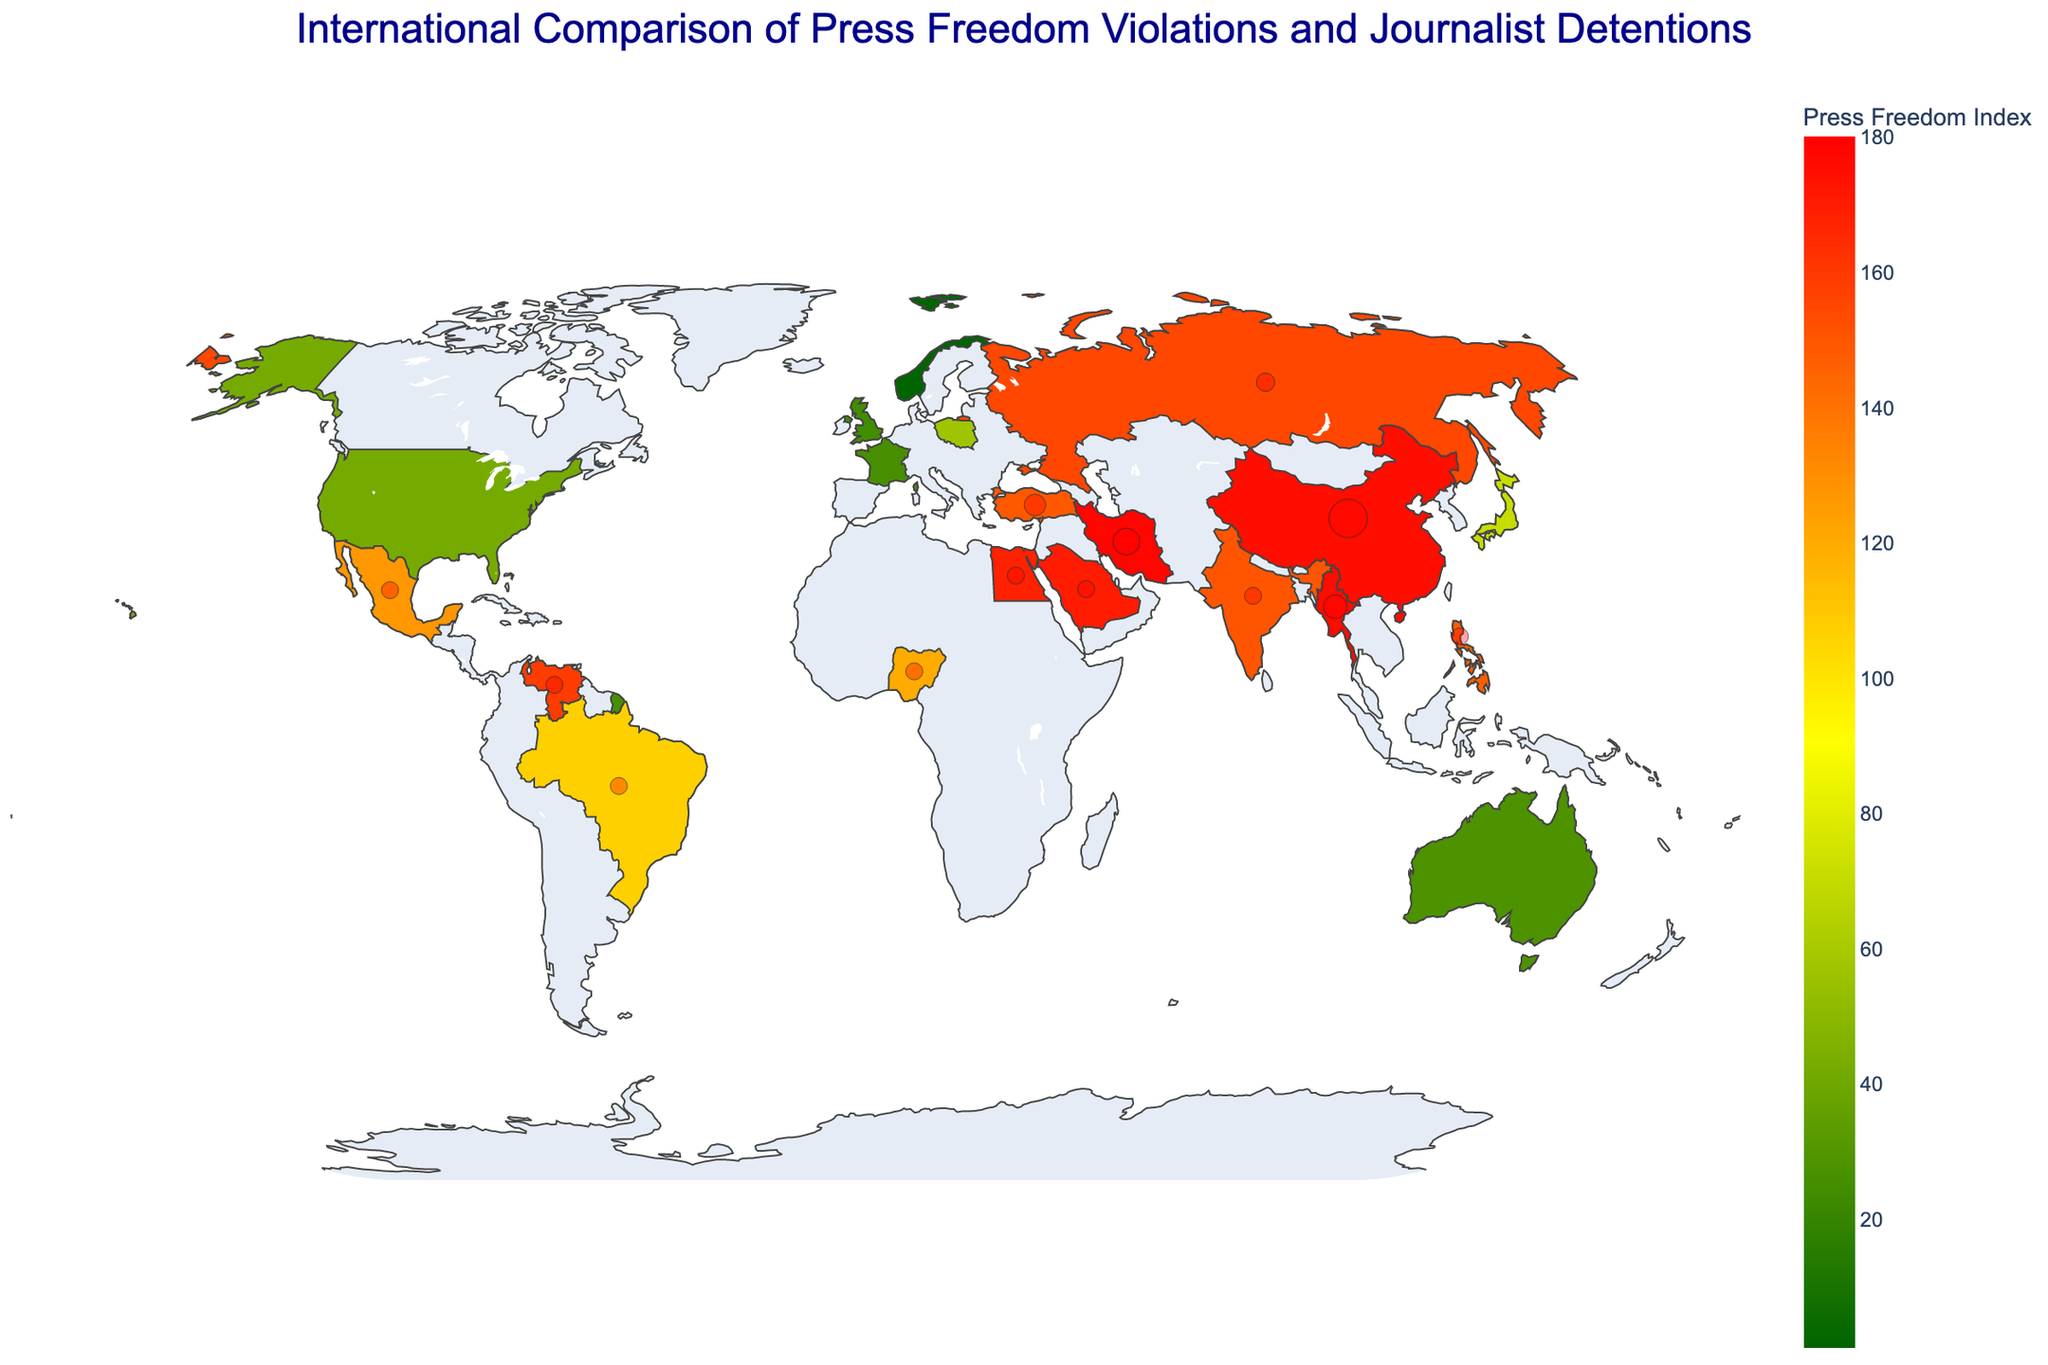which country has the highest press freedom index? The Press Freedom Index is a numerical value, and the higher the index, the worse the press freedom. Norway has the lowest (best) value of 1, so Norway has the best press freedom.
Answer: Norway which country has the most journalist detentions? The number of journalist detentions is represented by bubble size and text. China has the largest bubbles and the text shows it has 127 journalist detentions, the highest among the countries.
Answer: China which country has a press freedom index closest to 50? The Press Freedom Index is depicted by color. The U.S. has an index of 42 and Poland has an index of 57. The U.S. is closer to 50.
Answer: United States how many countries have a press freedom index above 150? Observing the color scale indicating a Press Freedom Index above 150, the countries are China, Myanmar, Iran, Saudi Arabia, Venezuela, and Egypt, making a total of 6.
Answer: 6 compare the press freedom index of China and India. Which is worse? China's Press Freedom Index is 175, while India's is 150. The higher the index, the worse the press freedom, so China is worse.
Answer: China which countries have zero journalist detentions despite having a press freedom index above 100? Countries with zero journalist detentions and a high Press Freedom Index (highlighted in the map) include Brazil and Nigeria.
Answer: Brazil, Nigeria which region has more countries with severe press freedom violations (index above 150)? By observing the map color-coding, regions like the Middle East (Iran, Saudi Arabia) and Asia (China, Myanmar) have more severe indices.
Answer: Middle East, Asia what is the average press freedom index of European countries presented in the plot? The European countries are Norway (1), France (26), Poland (57), United Kingdom (24). Average = (1+26+57+24)/4 = 27.
Answer: 27 identify and compare the countries with the same number of journalist detentions but different press freedom index values. Brazil and Nigeria both have 1 detention but different indices: Brazil (107) and Nigeria (120). Mexico and Philippines both have 2 detentions, Mexico (127) and Philippines (147).
Answer: Brazil, Nigeria & Mexico, Philippines 